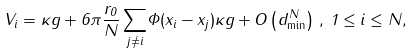<formula> <loc_0><loc_0><loc_500><loc_500>V _ { i } = \kappa g + 6 \pi \frac { r _ { 0 } } { N } \, \underset { j \neq i } { \sum } \Phi ( x _ { i } - x _ { j } ) \kappa g + O \left ( d _ { \min } ^ { N } \right ) \, , \, 1 \leq i \leq N ,</formula> 